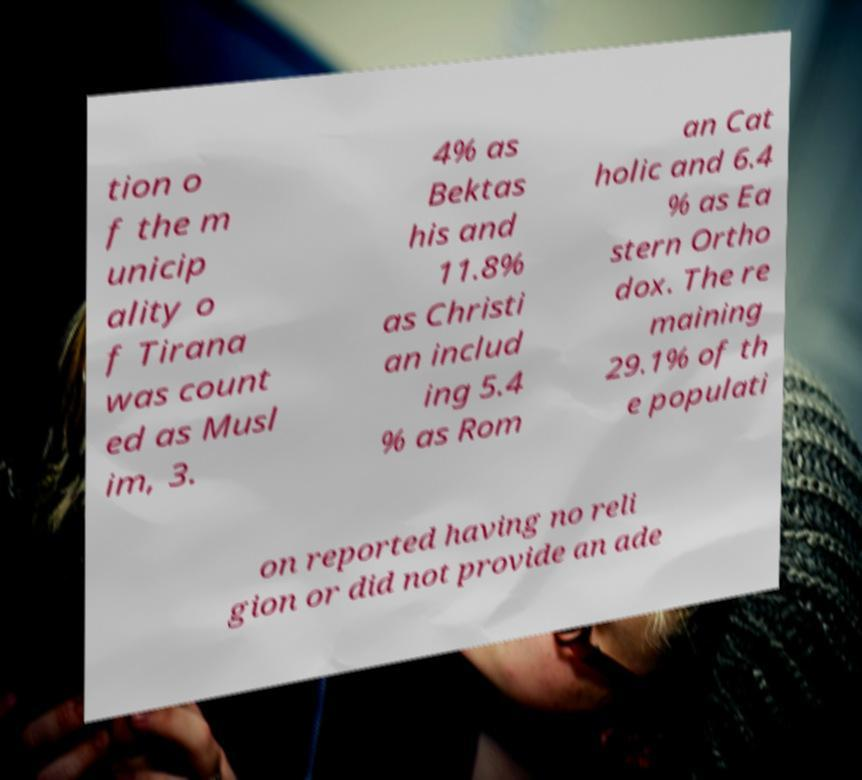For documentation purposes, I need the text within this image transcribed. Could you provide that? tion o f the m unicip ality o f Tirana was count ed as Musl im, 3. 4% as Bektas his and 11.8% as Christi an includ ing 5.4 % as Rom an Cat holic and 6.4 % as Ea stern Ortho dox. The re maining 29.1% of th e populati on reported having no reli gion or did not provide an ade 